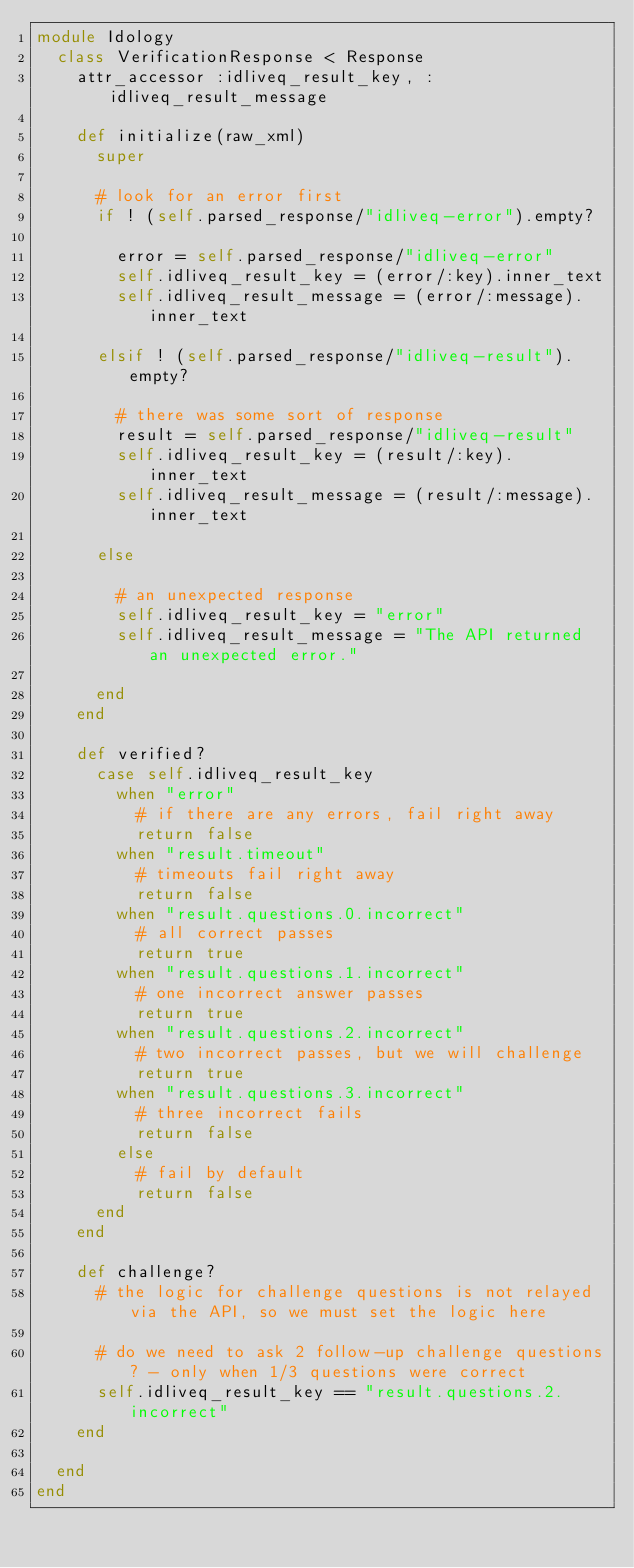<code> <loc_0><loc_0><loc_500><loc_500><_Ruby_>module Idology
  class VerificationResponse < Response
    attr_accessor :idliveq_result_key, :idliveq_result_message

    def initialize(raw_xml)
      super

      # look for an error first
      if ! (self.parsed_response/"idliveq-error").empty?

        error = self.parsed_response/"idliveq-error"
        self.idliveq_result_key = (error/:key).inner_text
        self.idliveq_result_message = (error/:message).inner_text

      elsif ! (self.parsed_response/"idliveq-result").empty?

        # there was some sort of response
        result = self.parsed_response/"idliveq-result"
        self.idliveq_result_key = (result/:key).inner_text
        self.idliveq_result_message = (result/:message).inner_text

      else

        # an unexpected response
        self.idliveq_result_key = "error"
        self.idliveq_result_message = "The API returned an unexpected error."

      end
    end

    def verified?
      case self.idliveq_result_key
        when "error"
          # if there are any errors, fail right away
          return false
        when "result.timeout"
          # timeouts fail right away
          return false
        when "result.questions.0.incorrect"
          # all correct passes
          return true
        when "result.questions.1.incorrect"
          # one incorrect answer passes
          return true
        when "result.questions.2.incorrect"
          # two incorrect passes, but we will challenge
          return true
        when "result.questions.3.incorrect"
          # three incorrect fails
          return false
        else
          # fail by default
          return false
      end
    end

    def challenge?
      # the logic for challenge questions is not relayed via the API, so we must set the logic here

      # do we need to ask 2 follow-up challenge questions? - only when 1/3 questions were correct
      self.idliveq_result_key == "result.questions.2.incorrect"
    end

  end
end</code> 